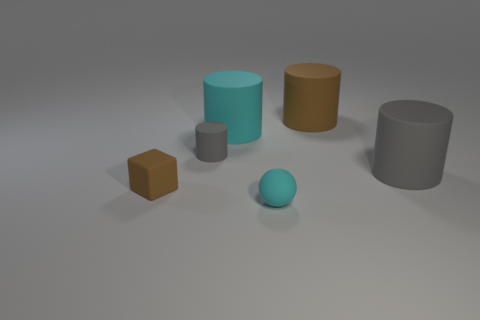How many other objects are there of the same color as the small matte block? Besides the small matte block, there is one other sphere-like object that shares a similar shade of color. It's important to observe the subtle differences because lighting can sometimes affect color perception in images. 